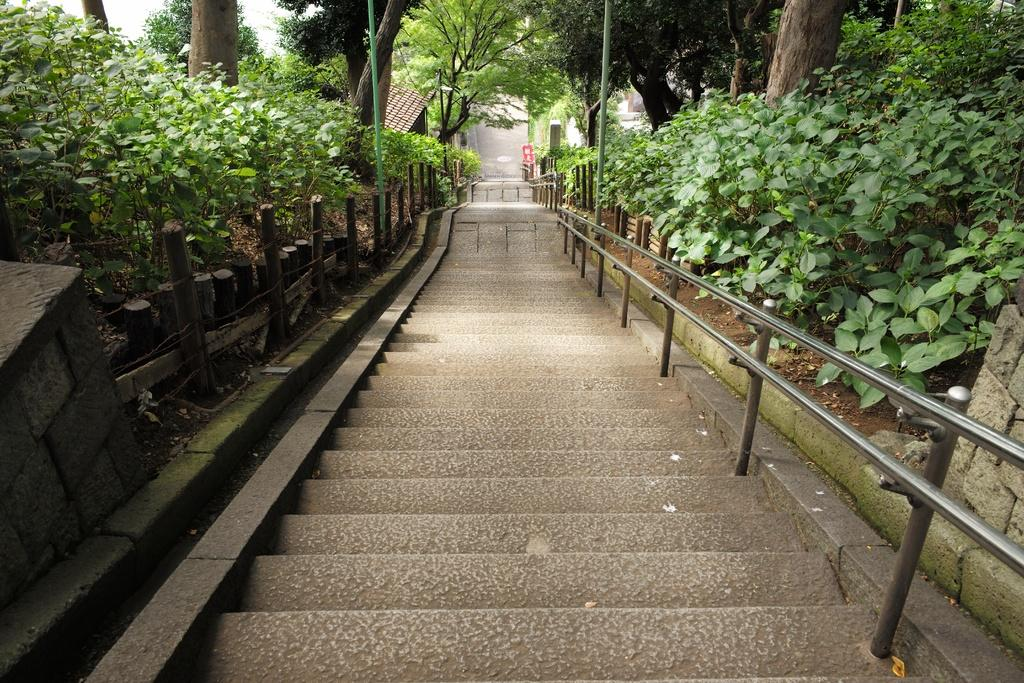What type of structure can be seen in the image? There is a house in the image. What can be found on the stairs in the image? The facts do not specify what is on the stairs, only that there are stairs present. What type of vegetation is visible in the image? There are plants and trees in the image. What type of pollution can be seen coming from the house in the image? There is no indication of pollution in the image; it only shows a house, stairs, plants, and trees. What type of flesh is visible on the plants in the image? There is no flesh present on the plants in the image; they are simply plants. 